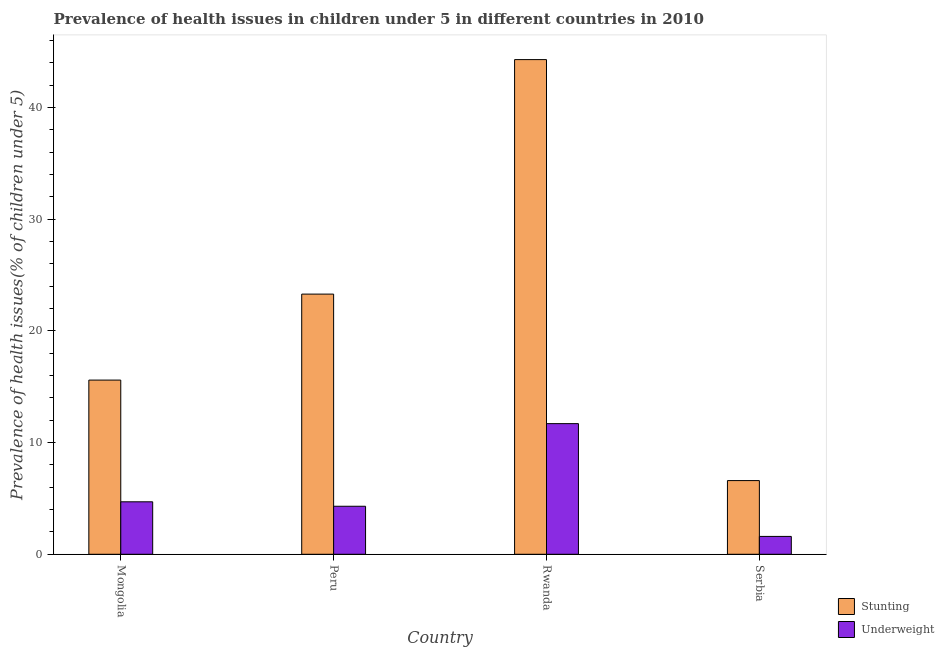How many bars are there on the 4th tick from the right?
Provide a short and direct response. 2. What is the label of the 1st group of bars from the left?
Give a very brief answer. Mongolia. What is the percentage of stunted children in Mongolia?
Ensure brevity in your answer.  15.6. Across all countries, what is the maximum percentage of stunted children?
Your response must be concise. 44.3. Across all countries, what is the minimum percentage of underweight children?
Provide a short and direct response. 1.6. In which country was the percentage of stunted children maximum?
Offer a very short reply. Rwanda. In which country was the percentage of underweight children minimum?
Provide a succinct answer. Serbia. What is the total percentage of stunted children in the graph?
Your answer should be very brief. 89.8. What is the difference between the percentage of underweight children in Mongolia and that in Serbia?
Your response must be concise. 3.1. What is the difference between the percentage of stunted children in Rwanda and the percentage of underweight children in Mongolia?
Ensure brevity in your answer.  39.6. What is the average percentage of stunted children per country?
Make the answer very short. 22.45. What is the difference between the percentage of underweight children and percentage of stunted children in Rwanda?
Provide a short and direct response. -32.6. What is the ratio of the percentage of stunted children in Mongolia to that in Rwanda?
Make the answer very short. 0.35. Is the percentage of underweight children in Mongolia less than that in Peru?
Ensure brevity in your answer.  No. Is the difference between the percentage of stunted children in Rwanda and Serbia greater than the difference between the percentage of underweight children in Rwanda and Serbia?
Make the answer very short. Yes. What is the difference between the highest and the second highest percentage of underweight children?
Your response must be concise. 7. What is the difference between the highest and the lowest percentage of stunted children?
Keep it short and to the point. 37.7. In how many countries, is the percentage of underweight children greater than the average percentage of underweight children taken over all countries?
Provide a succinct answer. 1. What does the 2nd bar from the left in Peru represents?
Keep it short and to the point. Underweight. What does the 2nd bar from the right in Rwanda represents?
Offer a terse response. Stunting. Are all the bars in the graph horizontal?
Ensure brevity in your answer.  No. How many legend labels are there?
Keep it short and to the point. 2. How are the legend labels stacked?
Offer a terse response. Vertical. What is the title of the graph?
Make the answer very short. Prevalence of health issues in children under 5 in different countries in 2010. Does "Lowest 10% of population" appear as one of the legend labels in the graph?
Provide a succinct answer. No. What is the label or title of the X-axis?
Ensure brevity in your answer.  Country. What is the label or title of the Y-axis?
Your response must be concise. Prevalence of health issues(% of children under 5). What is the Prevalence of health issues(% of children under 5) of Stunting in Mongolia?
Keep it short and to the point. 15.6. What is the Prevalence of health issues(% of children under 5) in Underweight in Mongolia?
Your answer should be very brief. 4.7. What is the Prevalence of health issues(% of children under 5) in Stunting in Peru?
Make the answer very short. 23.3. What is the Prevalence of health issues(% of children under 5) in Underweight in Peru?
Give a very brief answer. 4.3. What is the Prevalence of health issues(% of children under 5) in Stunting in Rwanda?
Provide a short and direct response. 44.3. What is the Prevalence of health issues(% of children under 5) of Underweight in Rwanda?
Make the answer very short. 11.7. What is the Prevalence of health issues(% of children under 5) in Stunting in Serbia?
Give a very brief answer. 6.6. What is the Prevalence of health issues(% of children under 5) in Underweight in Serbia?
Give a very brief answer. 1.6. Across all countries, what is the maximum Prevalence of health issues(% of children under 5) of Stunting?
Offer a terse response. 44.3. Across all countries, what is the maximum Prevalence of health issues(% of children under 5) in Underweight?
Your answer should be compact. 11.7. Across all countries, what is the minimum Prevalence of health issues(% of children under 5) of Stunting?
Offer a very short reply. 6.6. Across all countries, what is the minimum Prevalence of health issues(% of children under 5) of Underweight?
Offer a very short reply. 1.6. What is the total Prevalence of health issues(% of children under 5) in Stunting in the graph?
Ensure brevity in your answer.  89.8. What is the total Prevalence of health issues(% of children under 5) in Underweight in the graph?
Keep it short and to the point. 22.3. What is the difference between the Prevalence of health issues(% of children under 5) in Stunting in Mongolia and that in Peru?
Offer a terse response. -7.7. What is the difference between the Prevalence of health issues(% of children under 5) of Underweight in Mongolia and that in Peru?
Offer a terse response. 0.4. What is the difference between the Prevalence of health issues(% of children under 5) of Stunting in Mongolia and that in Rwanda?
Ensure brevity in your answer.  -28.7. What is the difference between the Prevalence of health issues(% of children under 5) in Stunting in Mongolia and that in Serbia?
Provide a short and direct response. 9. What is the difference between the Prevalence of health issues(% of children under 5) in Underweight in Mongolia and that in Serbia?
Provide a succinct answer. 3.1. What is the difference between the Prevalence of health issues(% of children under 5) in Underweight in Peru and that in Serbia?
Your response must be concise. 2.7. What is the difference between the Prevalence of health issues(% of children under 5) in Stunting in Rwanda and that in Serbia?
Provide a succinct answer. 37.7. What is the difference between the Prevalence of health issues(% of children under 5) in Underweight in Rwanda and that in Serbia?
Your response must be concise. 10.1. What is the difference between the Prevalence of health issues(% of children under 5) in Stunting in Mongolia and the Prevalence of health issues(% of children under 5) in Underweight in Peru?
Give a very brief answer. 11.3. What is the difference between the Prevalence of health issues(% of children under 5) in Stunting in Peru and the Prevalence of health issues(% of children under 5) in Underweight in Serbia?
Make the answer very short. 21.7. What is the difference between the Prevalence of health issues(% of children under 5) in Stunting in Rwanda and the Prevalence of health issues(% of children under 5) in Underweight in Serbia?
Make the answer very short. 42.7. What is the average Prevalence of health issues(% of children under 5) in Stunting per country?
Give a very brief answer. 22.45. What is the average Prevalence of health issues(% of children under 5) in Underweight per country?
Provide a short and direct response. 5.58. What is the difference between the Prevalence of health issues(% of children under 5) in Stunting and Prevalence of health issues(% of children under 5) in Underweight in Rwanda?
Your answer should be very brief. 32.6. What is the ratio of the Prevalence of health issues(% of children under 5) in Stunting in Mongolia to that in Peru?
Your response must be concise. 0.67. What is the ratio of the Prevalence of health issues(% of children under 5) of Underweight in Mongolia to that in Peru?
Give a very brief answer. 1.09. What is the ratio of the Prevalence of health issues(% of children under 5) of Stunting in Mongolia to that in Rwanda?
Make the answer very short. 0.35. What is the ratio of the Prevalence of health issues(% of children under 5) in Underweight in Mongolia to that in Rwanda?
Provide a succinct answer. 0.4. What is the ratio of the Prevalence of health issues(% of children under 5) of Stunting in Mongolia to that in Serbia?
Make the answer very short. 2.36. What is the ratio of the Prevalence of health issues(% of children under 5) of Underweight in Mongolia to that in Serbia?
Keep it short and to the point. 2.94. What is the ratio of the Prevalence of health issues(% of children under 5) in Stunting in Peru to that in Rwanda?
Provide a succinct answer. 0.53. What is the ratio of the Prevalence of health issues(% of children under 5) of Underweight in Peru to that in Rwanda?
Make the answer very short. 0.37. What is the ratio of the Prevalence of health issues(% of children under 5) of Stunting in Peru to that in Serbia?
Ensure brevity in your answer.  3.53. What is the ratio of the Prevalence of health issues(% of children under 5) of Underweight in Peru to that in Serbia?
Your answer should be compact. 2.69. What is the ratio of the Prevalence of health issues(% of children under 5) of Stunting in Rwanda to that in Serbia?
Your answer should be very brief. 6.71. What is the ratio of the Prevalence of health issues(% of children under 5) of Underweight in Rwanda to that in Serbia?
Give a very brief answer. 7.31. What is the difference between the highest and the lowest Prevalence of health issues(% of children under 5) in Stunting?
Provide a short and direct response. 37.7. What is the difference between the highest and the lowest Prevalence of health issues(% of children under 5) in Underweight?
Offer a very short reply. 10.1. 